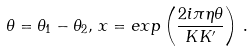<formula> <loc_0><loc_0><loc_500><loc_500>\theta = \theta _ { 1 } - \theta _ { 2 } , \, x = { e x p } \left ( \frac { 2 i \pi \eta \theta } { K K ^ { \prime } } \right ) \, .</formula> 